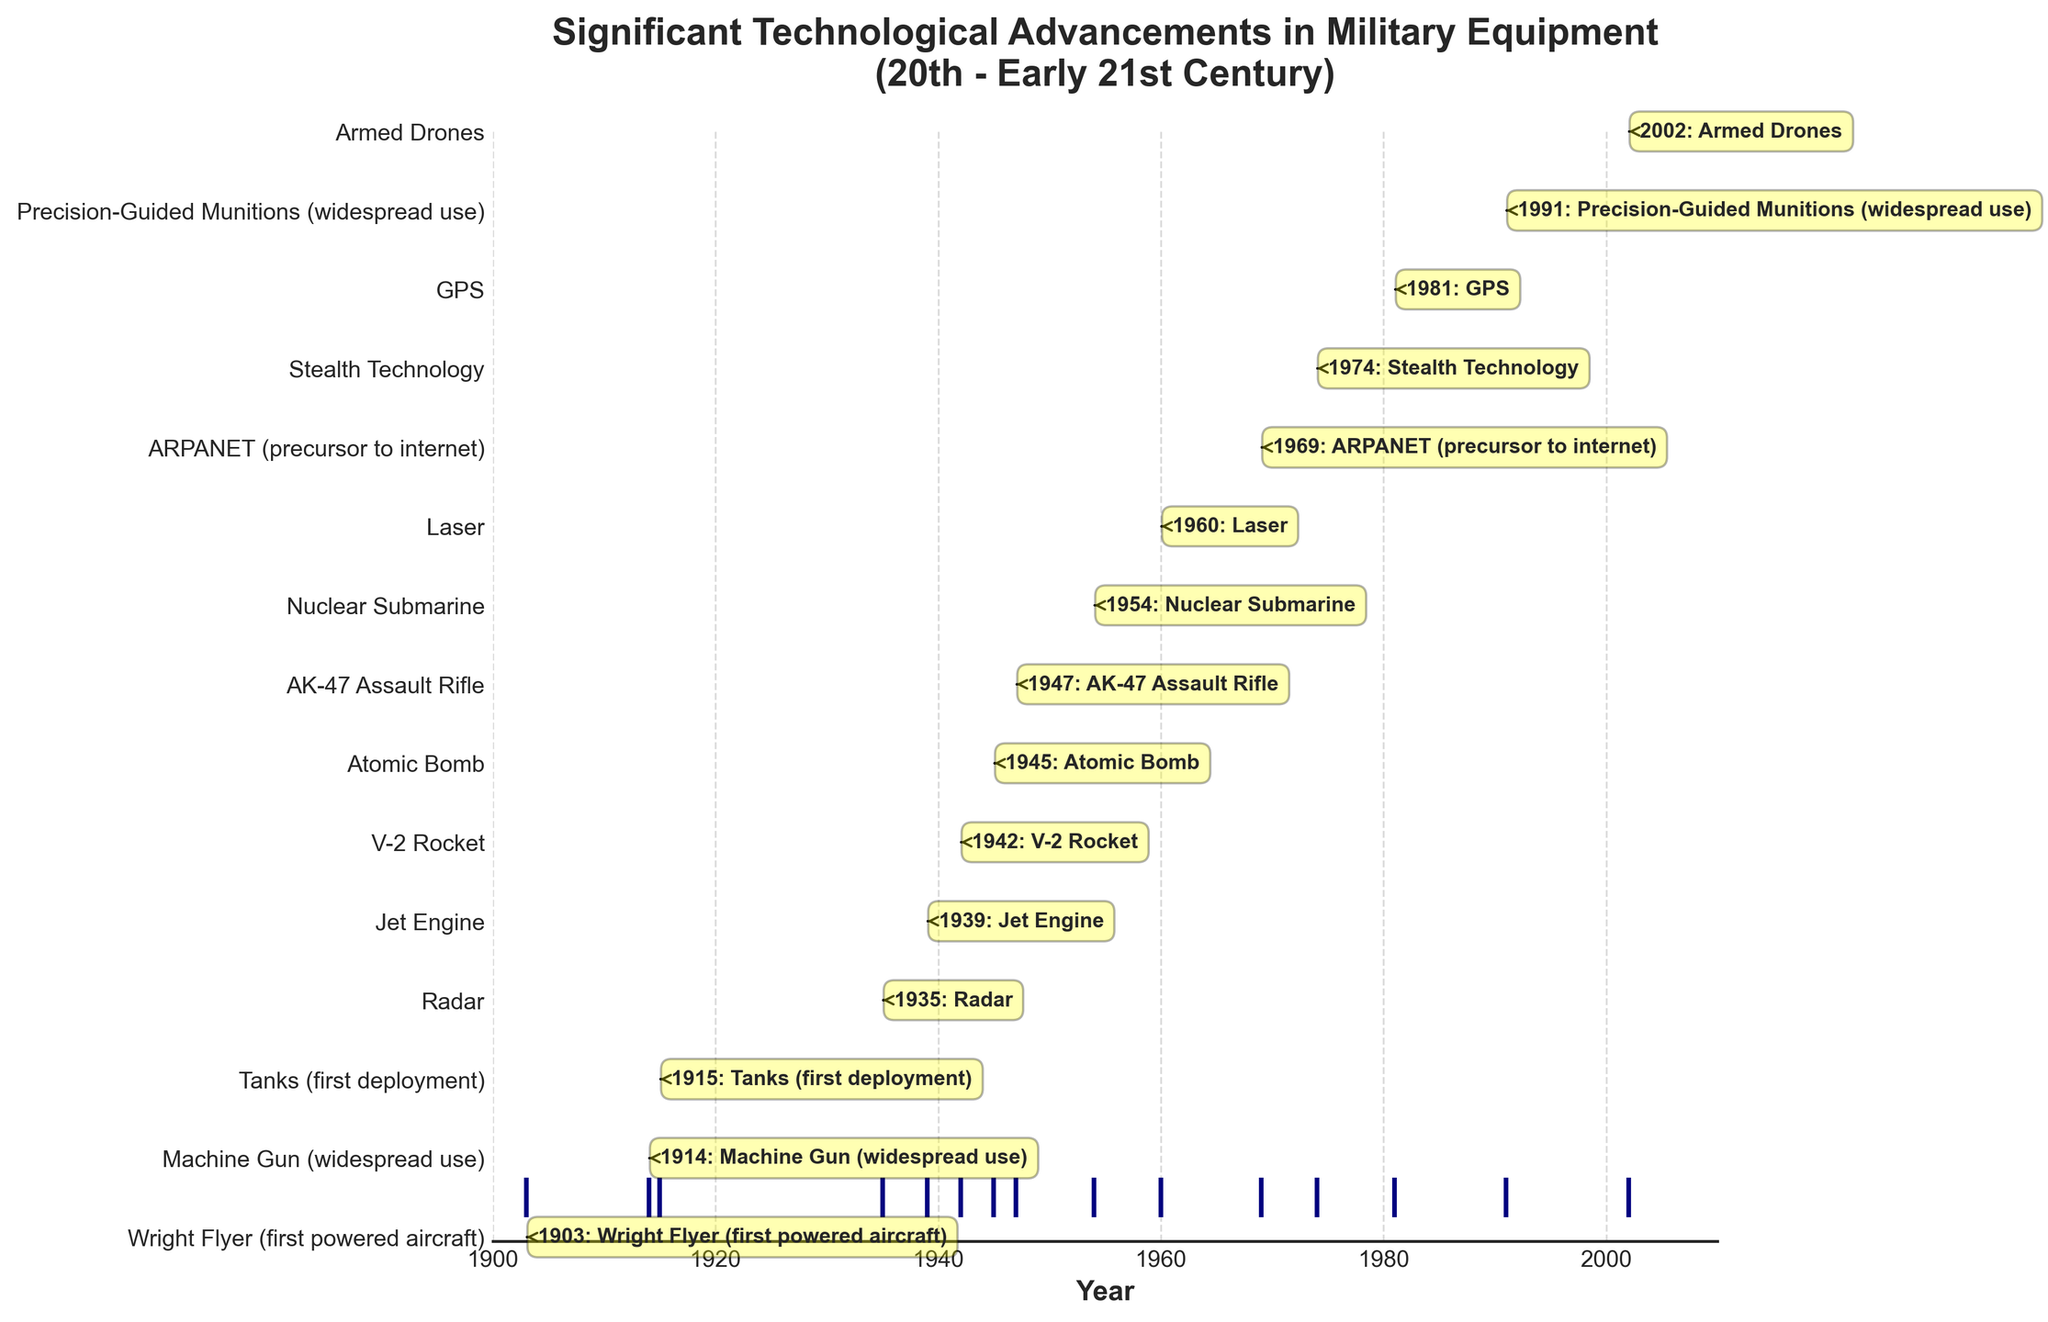What is the title of the figure? The title is displayed prominently at the top of the figure. It says "Significant Technological Advancements in Military Equipment (20th - Early 21st Century)"
Answer: Significant Technological Advancements in Military Equipment (20th - Early 21st Century) Which technology is represented at the year 1947? The technology at the year 1947 can be found on the respective position on the event plot with an annotation pointing to "AK-47 Assault Rifle".
Answer: AK-47 Assault Rifle How many significant technological advancements are noted in the figure? By counting the number of events marked on the event plot and the number of annotations, we can see there are 15 significant technological advancements.
Answer: 15 What is the first recorded significant technological advancement? The earliest year on the x-axis of the event plot is 1903, and the corresponding technology is "Wright Flyer (first powered aircraft)".
Answer: Wright Flyer (first powered aircraft) Which technology appeared first: Radar or Stealth Technology? Finding the annotated years for both technologies, Radar appears in 1935 while Stealth Technology appears in 1974, thus Radar appeared first.
Answer: Radar What's the difference in years between the first powered aircraft and the atomic bomb? The Wright Flyer first flew in 1903, and the Atomic Bomb was first used in 1945. The difference between these years is 1945 - 1903 = 42 years.
Answer: 42 years Which technologies were introduced during World War II (1939-1945)? Checking the years corresponding to the World War II period, the technologies introduced are the Jet Engine (1939), V-2 Rocket (1942), and Atomic Bomb (1945).
Answer: Jet Engine, V-2 Rocket, Atomic Bomb What significant technology was introduced in 1969 and how is it relevant today? The event plot shows an annotation for ARPANET in 1969. ARPANET is considered the precursor to the modern internet, which is highly relevant today.
Answer: ARPANET, precursor to the internet Is there any gap in years where no major technological advancements are recorded in the plot? By examining the differences in the annotated years, there is a notable gap between 2002 (Armed Drones) and the next closest year earlier at 1991 (Precision-Guided Munitions), which is 11 years.
Answer: 11 years What technologies were developed during the Cold War period (1947-1991)? Identifying the years within the Cold War period, the following advancements occurred: AK-47 Assault Rifle (1947), Nuclear Submarine (1954), Laser (1960), ARPANET (1969), Stealth Technology (1974), and GPS (1981).
Answer: AK-47 Assault Rifle, Nuclear Submarine, Laser, ARPANET, Stealth Technology, GPS 